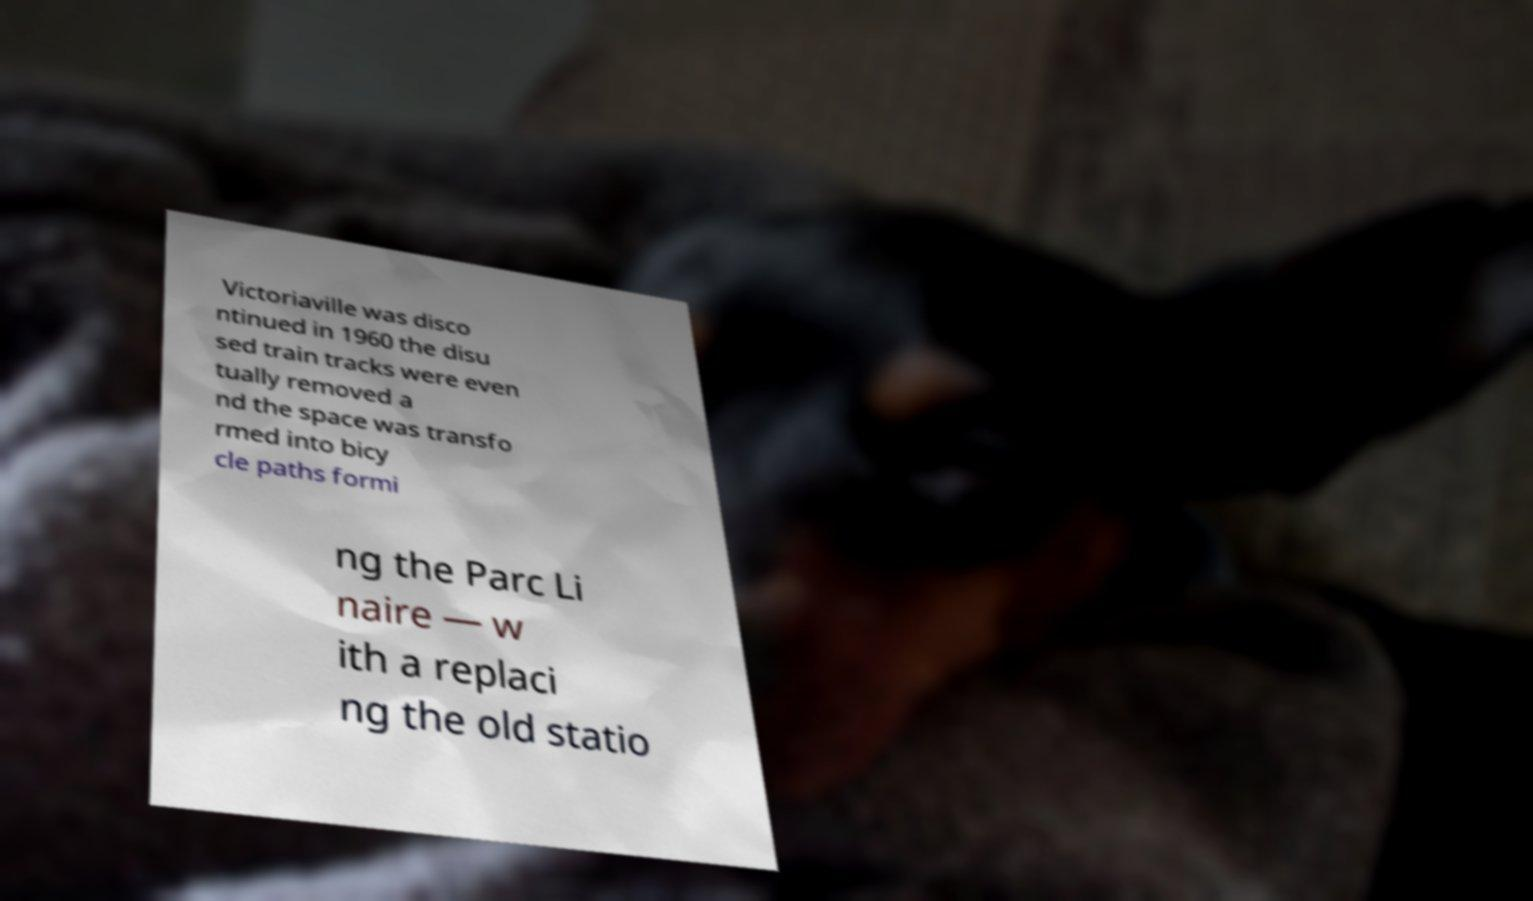Can you read and provide the text displayed in the image?This photo seems to have some interesting text. Can you extract and type it out for me? Victoriaville was disco ntinued in 1960 the disu sed train tracks were even tually removed a nd the space was transfo rmed into bicy cle paths formi ng the Parc Li naire — w ith a replaci ng the old statio 